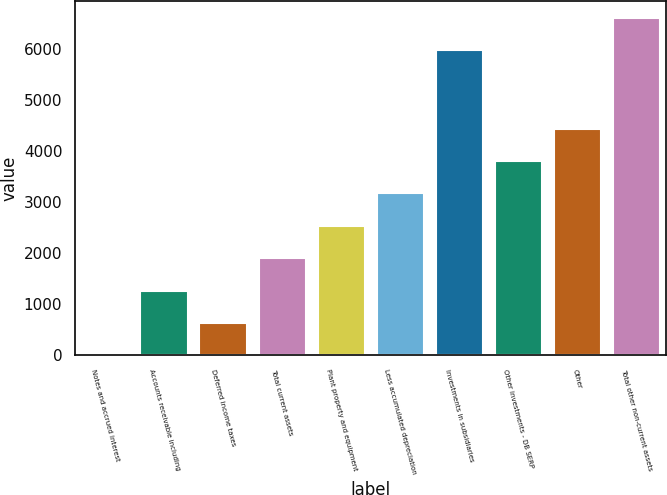<chart> <loc_0><loc_0><loc_500><loc_500><bar_chart><fcel>Notes and accrued interest<fcel>Accounts receivable including<fcel>Deferred income taxes<fcel>Total current assets<fcel>Plant property and equipment<fcel>Less accumulated depreciation<fcel>Investments in subsidiaries<fcel>Other investments - DB SERP<fcel>Other<fcel>Total other non-current assets<nl><fcel>2<fcel>1268.4<fcel>635.2<fcel>1901.6<fcel>2534.8<fcel>3168<fcel>5961<fcel>3801.2<fcel>4434.4<fcel>6594.2<nl></chart> 